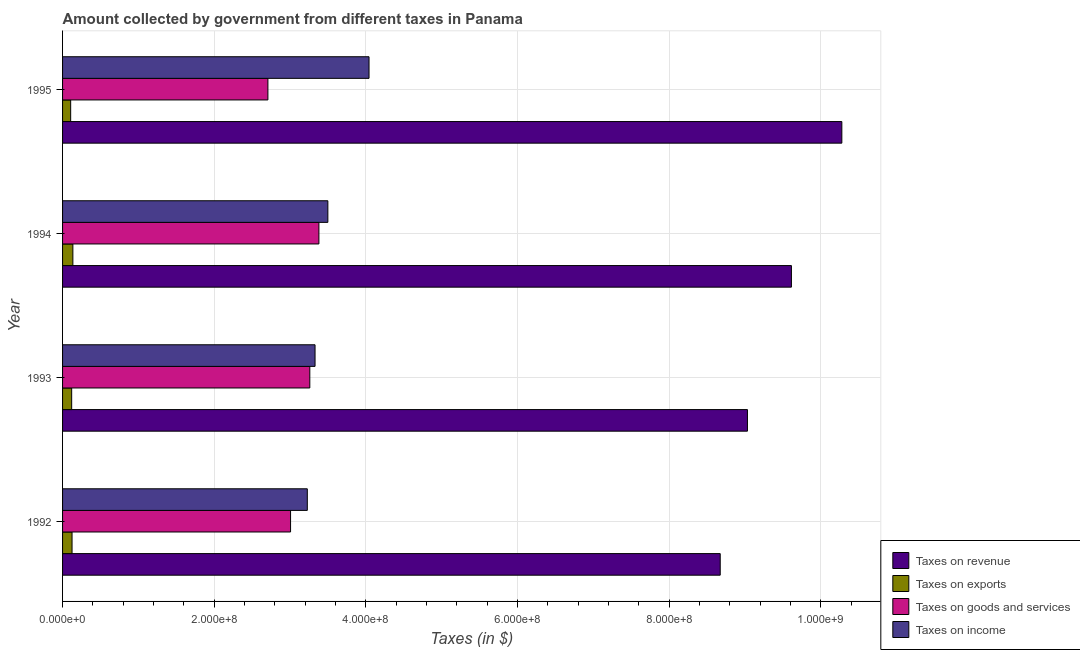How many groups of bars are there?
Keep it short and to the point. 4. Are the number of bars per tick equal to the number of legend labels?
Provide a succinct answer. Yes. Are the number of bars on each tick of the Y-axis equal?
Your response must be concise. Yes. What is the label of the 1st group of bars from the top?
Provide a short and direct response. 1995. In how many cases, is the number of bars for a given year not equal to the number of legend labels?
Ensure brevity in your answer.  0. What is the amount collected as tax on exports in 1994?
Provide a succinct answer. 1.36e+07. Across all years, what is the maximum amount collected as tax on goods?
Keep it short and to the point. 3.38e+08. Across all years, what is the minimum amount collected as tax on goods?
Ensure brevity in your answer.  2.71e+08. What is the total amount collected as tax on revenue in the graph?
Offer a very short reply. 3.76e+09. What is the difference between the amount collected as tax on exports in 1993 and that in 1994?
Provide a short and direct response. -1.60e+06. What is the difference between the amount collected as tax on income in 1994 and the amount collected as tax on revenue in 1995?
Offer a very short reply. -6.78e+08. What is the average amount collected as tax on revenue per year?
Your answer should be very brief. 9.40e+08. In the year 1995, what is the difference between the amount collected as tax on exports and amount collected as tax on income?
Keep it short and to the point. -3.94e+08. What is the ratio of the amount collected as tax on revenue in 1993 to that in 1995?
Make the answer very short. 0.88. Is the difference between the amount collected as tax on income in 1992 and 1993 greater than the difference between the amount collected as tax on goods in 1992 and 1993?
Your response must be concise. Yes. What is the difference between the highest and the second highest amount collected as tax on revenue?
Offer a very short reply. 6.65e+07. What is the difference between the highest and the lowest amount collected as tax on income?
Provide a short and direct response. 8.14e+07. In how many years, is the amount collected as tax on exports greater than the average amount collected as tax on exports taken over all years?
Offer a very short reply. 2. Is the sum of the amount collected as tax on revenue in 1993 and 1995 greater than the maximum amount collected as tax on exports across all years?
Your answer should be compact. Yes. What does the 4th bar from the top in 1995 represents?
Ensure brevity in your answer.  Taxes on revenue. What does the 1st bar from the bottom in 1994 represents?
Offer a terse response. Taxes on revenue. How many years are there in the graph?
Keep it short and to the point. 4. What is the difference between two consecutive major ticks on the X-axis?
Your answer should be very brief. 2.00e+08. Does the graph contain any zero values?
Your answer should be very brief. No. Does the graph contain grids?
Your answer should be very brief. Yes. Where does the legend appear in the graph?
Offer a very short reply. Bottom right. What is the title of the graph?
Give a very brief answer. Amount collected by government from different taxes in Panama. Does "Argument" appear as one of the legend labels in the graph?
Offer a terse response. No. What is the label or title of the X-axis?
Offer a very short reply. Taxes (in $). What is the label or title of the Y-axis?
Provide a succinct answer. Year. What is the Taxes (in $) of Taxes on revenue in 1992?
Provide a succinct answer. 8.67e+08. What is the Taxes (in $) of Taxes on exports in 1992?
Provide a succinct answer. 1.25e+07. What is the Taxes (in $) of Taxes on goods and services in 1992?
Provide a short and direct response. 3.01e+08. What is the Taxes (in $) of Taxes on income in 1992?
Provide a succinct answer. 3.23e+08. What is the Taxes (in $) in Taxes on revenue in 1993?
Your response must be concise. 9.03e+08. What is the Taxes (in $) in Taxes on goods and services in 1993?
Ensure brevity in your answer.  3.26e+08. What is the Taxes (in $) in Taxes on income in 1993?
Your answer should be compact. 3.33e+08. What is the Taxes (in $) in Taxes on revenue in 1994?
Your answer should be compact. 9.61e+08. What is the Taxes (in $) of Taxes on exports in 1994?
Your answer should be very brief. 1.36e+07. What is the Taxes (in $) of Taxes on goods and services in 1994?
Offer a very short reply. 3.38e+08. What is the Taxes (in $) in Taxes on income in 1994?
Offer a terse response. 3.50e+08. What is the Taxes (in $) of Taxes on revenue in 1995?
Provide a short and direct response. 1.03e+09. What is the Taxes (in $) in Taxes on exports in 1995?
Provide a short and direct response. 1.07e+07. What is the Taxes (in $) in Taxes on goods and services in 1995?
Give a very brief answer. 2.71e+08. What is the Taxes (in $) of Taxes on income in 1995?
Your answer should be compact. 4.04e+08. Across all years, what is the maximum Taxes (in $) of Taxes on revenue?
Offer a very short reply. 1.03e+09. Across all years, what is the maximum Taxes (in $) of Taxes on exports?
Ensure brevity in your answer.  1.36e+07. Across all years, what is the maximum Taxes (in $) of Taxes on goods and services?
Give a very brief answer. 3.38e+08. Across all years, what is the maximum Taxes (in $) in Taxes on income?
Your answer should be compact. 4.04e+08. Across all years, what is the minimum Taxes (in $) of Taxes on revenue?
Keep it short and to the point. 8.67e+08. Across all years, what is the minimum Taxes (in $) of Taxes on exports?
Your answer should be very brief. 1.07e+07. Across all years, what is the minimum Taxes (in $) of Taxes on goods and services?
Provide a succinct answer. 2.71e+08. Across all years, what is the minimum Taxes (in $) of Taxes on income?
Your response must be concise. 3.23e+08. What is the total Taxes (in $) of Taxes on revenue in the graph?
Provide a succinct answer. 3.76e+09. What is the total Taxes (in $) in Taxes on exports in the graph?
Provide a succinct answer. 4.88e+07. What is the total Taxes (in $) in Taxes on goods and services in the graph?
Ensure brevity in your answer.  1.24e+09. What is the total Taxes (in $) in Taxes on income in the graph?
Provide a succinct answer. 1.41e+09. What is the difference between the Taxes (in $) of Taxes on revenue in 1992 and that in 1993?
Your response must be concise. -3.59e+07. What is the difference between the Taxes (in $) of Taxes on exports in 1992 and that in 1993?
Offer a terse response. 5.00e+05. What is the difference between the Taxes (in $) of Taxes on goods and services in 1992 and that in 1993?
Provide a succinct answer. -2.54e+07. What is the difference between the Taxes (in $) of Taxes on income in 1992 and that in 1993?
Provide a short and direct response. -1.02e+07. What is the difference between the Taxes (in $) in Taxes on revenue in 1992 and that in 1994?
Make the answer very short. -9.39e+07. What is the difference between the Taxes (in $) of Taxes on exports in 1992 and that in 1994?
Give a very brief answer. -1.10e+06. What is the difference between the Taxes (in $) of Taxes on goods and services in 1992 and that in 1994?
Keep it short and to the point. -3.74e+07. What is the difference between the Taxes (in $) of Taxes on income in 1992 and that in 1994?
Give a very brief answer. -2.71e+07. What is the difference between the Taxes (in $) of Taxes on revenue in 1992 and that in 1995?
Give a very brief answer. -1.60e+08. What is the difference between the Taxes (in $) of Taxes on exports in 1992 and that in 1995?
Provide a succinct answer. 1.80e+06. What is the difference between the Taxes (in $) of Taxes on goods and services in 1992 and that in 1995?
Keep it short and to the point. 2.99e+07. What is the difference between the Taxes (in $) of Taxes on income in 1992 and that in 1995?
Your answer should be very brief. -8.14e+07. What is the difference between the Taxes (in $) of Taxes on revenue in 1993 and that in 1994?
Offer a very short reply. -5.80e+07. What is the difference between the Taxes (in $) of Taxes on exports in 1993 and that in 1994?
Provide a short and direct response. -1.60e+06. What is the difference between the Taxes (in $) of Taxes on goods and services in 1993 and that in 1994?
Your response must be concise. -1.20e+07. What is the difference between the Taxes (in $) of Taxes on income in 1993 and that in 1994?
Provide a short and direct response. -1.69e+07. What is the difference between the Taxes (in $) in Taxes on revenue in 1993 and that in 1995?
Give a very brief answer. -1.24e+08. What is the difference between the Taxes (in $) of Taxes on exports in 1993 and that in 1995?
Your response must be concise. 1.30e+06. What is the difference between the Taxes (in $) in Taxes on goods and services in 1993 and that in 1995?
Your answer should be very brief. 5.53e+07. What is the difference between the Taxes (in $) in Taxes on income in 1993 and that in 1995?
Your response must be concise. -7.12e+07. What is the difference between the Taxes (in $) of Taxes on revenue in 1994 and that in 1995?
Your response must be concise. -6.65e+07. What is the difference between the Taxes (in $) of Taxes on exports in 1994 and that in 1995?
Give a very brief answer. 2.90e+06. What is the difference between the Taxes (in $) in Taxes on goods and services in 1994 and that in 1995?
Ensure brevity in your answer.  6.73e+07. What is the difference between the Taxes (in $) in Taxes on income in 1994 and that in 1995?
Ensure brevity in your answer.  -5.43e+07. What is the difference between the Taxes (in $) of Taxes on revenue in 1992 and the Taxes (in $) of Taxes on exports in 1993?
Your answer should be very brief. 8.55e+08. What is the difference between the Taxes (in $) of Taxes on revenue in 1992 and the Taxes (in $) of Taxes on goods and services in 1993?
Offer a very short reply. 5.41e+08. What is the difference between the Taxes (in $) of Taxes on revenue in 1992 and the Taxes (in $) of Taxes on income in 1993?
Keep it short and to the point. 5.34e+08. What is the difference between the Taxes (in $) in Taxes on exports in 1992 and the Taxes (in $) in Taxes on goods and services in 1993?
Give a very brief answer. -3.14e+08. What is the difference between the Taxes (in $) in Taxes on exports in 1992 and the Taxes (in $) in Taxes on income in 1993?
Ensure brevity in your answer.  -3.20e+08. What is the difference between the Taxes (in $) in Taxes on goods and services in 1992 and the Taxes (in $) in Taxes on income in 1993?
Give a very brief answer. -3.23e+07. What is the difference between the Taxes (in $) of Taxes on revenue in 1992 and the Taxes (in $) of Taxes on exports in 1994?
Your answer should be very brief. 8.54e+08. What is the difference between the Taxes (in $) in Taxes on revenue in 1992 and the Taxes (in $) in Taxes on goods and services in 1994?
Your response must be concise. 5.29e+08. What is the difference between the Taxes (in $) of Taxes on revenue in 1992 and the Taxes (in $) of Taxes on income in 1994?
Your response must be concise. 5.18e+08. What is the difference between the Taxes (in $) of Taxes on exports in 1992 and the Taxes (in $) of Taxes on goods and services in 1994?
Your answer should be very brief. -3.26e+08. What is the difference between the Taxes (in $) in Taxes on exports in 1992 and the Taxes (in $) in Taxes on income in 1994?
Offer a terse response. -3.37e+08. What is the difference between the Taxes (in $) in Taxes on goods and services in 1992 and the Taxes (in $) in Taxes on income in 1994?
Your response must be concise. -4.92e+07. What is the difference between the Taxes (in $) in Taxes on revenue in 1992 and the Taxes (in $) in Taxes on exports in 1995?
Ensure brevity in your answer.  8.57e+08. What is the difference between the Taxes (in $) of Taxes on revenue in 1992 and the Taxes (in $) of Taxes on goods and services in 1995?
Your response must be concise. 5.97e+08. What is the difference between the Taxes (in $) in Taxes on revenue in 1992 and the Taxes (in $) in Taxes on income in 1995?
Keep it short and to the point. 4.63e+08. What is the difference between the Taxes (in $) of Taxes on exports in 1992 and the Taxes (in $) of Taxes on goods and services in 1995?
Offer a very short reply. -2.58e+08. What is the difference between the Taxes (in $) of Taxes on exports in 1992 and the Taxes (in $) of Taxes on income in 1995?
Make the answer very short. -3.92e+08. What is the difference between the Taxes (in $) in Taxes on goods and services in 1992 and the Taxes (in $) in Taxes on income in 1995?
Your answer should be very brief. -1.04e+08. What is the difference between the Taxes (in $) of Taxes on revenue in 1993 and the Taxes (in $) of Taxes on exports in 1994?
Your answer should be compact. 8.90e+08. What is the difference between the Taxes (in $) in Taxes on revenue in 1993 and the Taxes (in $) in Taxes on goods and services in 1994?
Your response must be concise. 5.65e+08. What is the difference between the Taxes (in $) of Taxes on revenue in 1993 and the Taxes (in $) of Taxes on income in 1994?
Your response must be concise. 5.53e+08. What is the difference between the Taxes (in $) in Taxes on exports in 1993 and the Taxes (in $) in Taxes on goods and services in 1994?
Provide a short and direct response. -3.26e+08. What is the difference between the Taxes (in $) in Taxes on exports in 1993 and the Taxes (in $) in Taxes on income in 1994?
Offer a terse response. -3.38e+08. What is the difference between the Taxes (in $) of Taxes on goods and services in 1993 and the Taxes (in $) of Taxes on income in 1994?
Offer a terse response. -2.38e+07. What is the difference between the Taxes (in $) of Taxes on revenue in 1993 and the Taxes (in $) of Taxes on exports in 1995?
Ensure brevity in your answer.  8.93e+08. What is the difference between the Taxes (in $) in Taxes on revenue in 1993 and the Taxes (in $) in Taxes on goods and services in 1995?
Make the answer very short. 6.32e+08. What is the difference between the Taxes (in $) in Taxes on revenue in 1993 and the Taxes (in $) in Taxes on income in 1995?
Offer a terse response. 4.99e+08. What is the difference between the Taxes (in $) in Taxes on exports in 1993 and the Taxes (in $) in Taxes on goods and services in 1995?
Keep it short and to the point. -2.59e+08. What is the difference between the Taxes (in $) in Taxes on exports in 1993 and the Taxes (in $) in Taxes on income in 1995?
Your response must be concise. -3.92e+08. What is the difference between the Taxes (in $) in Taxes on goods and services in 1993 and the Taxes (in $) in Taxes on income in 1995?
Ensure brevity in your answer.  -7.81e+07. What is the difference between the Taxes (in $) of Taxes on revenue in 1994 and the Taxes (in $) of Taxes on exports in 1995?
Offer a terse response. 9.51e+08. What is the difference between the Taxes (in $) in Taxes on revenue in 1994 and the Taxes (in $) in Taxes on goods and services in 1995?
Provide a short and direct response. 6.90e+08. What is the difference between the Taxes (in $) in Taxes on revenue in 1994 and the Taxes (in $) in Taxes on income in 1995?
Keep it short and to the point. 5.57e+08. What is the difference between the Taxes (in $) of Taxes on exports in 1994 and the Taxes (in $) of Taxes on goods and services in 1995?
Ensure brevity in your answer.  -2.57e+08. What is the difference between the Taxes (in $) of Taxes on exports in 1994 and the Taxes (in $) of Taxes on income in 1995?
Give a very brief answer. -3.91e+08. What is the difference between the Taxes (in $) in Taxes on goods and services in 1994 and the Taxes (in $) in Taxes on income in 1995?
Provide a short and direct response. -6.61e+07. What is the average Taxes (in $) of Taxes on revenue per year?
Your answer should be compact. 9.40e+08. What is the average Taxes (in $) in Taxes on exports per year?
Provide a succinct answer. 1.22e+07. What is the average Taxes (in $) of Taxes on goods and services per year?
Your response must be concise. 3.09e+08. What is the average Taxes (in $) in Taxes on income per year?
Ensure brevity in your answer.  3.52e+08. In the year 1992, what is the difference between the Taxes (in $) of Taxes on revenue and Taxes (in $) of Taxes on exports?
Keep it short and to the point. 8.55e+08. In the year 1992, what is the difference between the Taxes (in $) of Taxes on revenue and Taxes (in $) of Taxes on goods and services?
Your answer should be very brief. 5.67e+08. In the year 1992, what is the difference between the Taxes (in $) in Taxes on revenue and Taxes (in $) in Taxes on income?
Offer a terse response. 5.45e+08. In the year 1992, what is the difference between the Taxes (in $) of Taxes on exports and Taxes (in $) of Taxes on goods and services?
Provide a succinct answer. -2.88e+08. In the year 1992, what is the difference between the Taxes (in $) in Taxes on exports and Taxes (in $) in Taxes on income?
Offer a terse response. -3.10e+08. In the year 1992, what is the difference between the Taxes (in $) in Taxes on goods and services and Taxes (in $) in Taxes on income?
Your response must be concise. -2.21e+07. In the year 1993, what is the difference between the Taxes (in $) in Taxes on revenue and Taxes (in $) in Taxes on exports?
Provide a succinct answer. 8.91e+08. In the year 1993, what is the difference between the Taxes (in $) of Taxes on revenue and Taxes (in $) of Taxes on goods and services?
Keep it short and to the point. 5.77e+08. In the year 1993, what is the difference between the Taxes (in $) in Taxes on revenue and Taxes (in $) in Taxes on income?
Your answer should be very brief. 5.70e+08. In the year 1993, what is the difference between the Taxes (in $) of Taxes on exports and Taxes (in $) of Taxes on goods and services?
Your response must be concise. -3.14e+08. In the year 1993, what is the difference between the Taxes (in $) of Taxes on exports and Taxes (in $) of Taxes on income?
Your answer should be very brief. -3.21e+08. In the year 1993, what is the difference between the Taxes (in $) of Taxes on goods and services and Taxes (in $) of Taxes on income?
Your answer should be compact. -6.90e+06. In the year 1994, what is the difference between the Taxes (in $) of Taxes on revenue and Taxes (in $) of Taxes on exports?
Offer a terse response. 9.48e+08. In the year 1994, what is the difference between the Taxes (in $) in Taxes on revenue and Taxes (in $) in Taxes on goods and services?
Give a very brief answer. 6.23e+08. In the year 1994, what is the difference between the Taxes (in $) of Taxes on revenue and Taxes (in $) of Taxes on income?
Offer a terse response. 6.11e+08. In the year 1994, what is the difference between the Taxes (in $) in Taxes on exports and Taxes (in $) in Taxes on goods and services?
Offer a terse response. -3.24e+08. In the year 1994, what is the difference between the Taxes (in $) of Taxes on exports and Taxes (in $) of Taxes on income?
Ensure brevity in your answer.  -3.36e+08. In the year 1994, what is the difference between the Taxes (in $) of Taxes on goods and services and Taxes (in $) of Taxes on income?
Offer a terse response. -1.18e+07. In the year 1995, what is the difference between the Taxes (in $) in Taxes on revenue and Taxes (in $) in Taxes on exports?
Make the answer very short. 1.02e+09. In the year 1995, what is the difference between the Taxes (in $) of Taxes on revenue and Taxes (in $) of Taxes on goods and services?
Offer a very short reply. 7.57e+08. In the year 1995, what is the difference between the Taxes (in $) of Taxes on revenue and Taxes (in $) of Taxes on income?
Your answer should be very brief. 6.24e+08. In the year 1995, what is the difference between the Taxes (in $) in Taxes on exports and Taxes (in $) in Taxes on goods and services?
Your answer should be compact. -2.60e+08. In the year 1995, what is the difference between the Taxes (in $) in Taxes on exports and Taxes (in $) in Taxes on income?
Provide a short and direct response. -3.94e+08. In the year 1995, what is the difference between the Taxes (in $) of Taxes on goods and services and Taxes (in $) of Taxes on income?
Keep it short and to the point. -1.33e+08. What is the ratio of the Taxes (in $) in Taxes on revenue in 1992 to that in 1993?
Keep it short and to the point. 0.96. What is the ratio of the Taxes (in $) in Taxes on exports in 1992 to that in 1993?
Your answer should be very brief. 1.04. What is the ratio of the Taxes (in $) of Taxes on goods and services in 1992 to that in 1993?
Your response must be concise. 0.92. What is the ratio of the Taxes (in $) in Taxes on income in 1992 to that in 1993?
Ensure brevity in your answer.  0.97. What is the ratio of the Taxes (in $) of Taxes on revenue in 1992 to that in 1994?
Your answer should be compact. 0.9. What is the ratio of the Taxes (in $) in Taxes on exports in 1992 to that in 1994?
Keep it short and to the point. 0.92. What is the ratio of the Taxes (in $) of Taxes on goods and services in 1992 to that in 1994?
Ensure brevity in your answer.  0.89. What is the ratio of the Taxes (in $) in Taxes on income in 1992 to that in 1994?
Keep it short and to the point. 0.92. What is the ratio of the Taxes (in $) of Taxes on revenue in 1992 to that in 1995?
Make the answer very short. 0.84. What is the ratio of the Taxes (in $) of Taxes on exports in 1992 to that in 1995?
Your answer should be very brief. 1.17. What is the ratio of the Taxes (in $) in Taxes on goods and services in 1992 to that in 1995?
Make the answer very short. 1.11. What is the ratio of the Taxes (in $) in Taxes on income in 1992 to that in 1995?
Your answer should be compact. 0.8. What is the ratio of the Taxes (in $) in Taxes on revenue in 1993 to that in 1994?
Ensure brevity in your answer.  0.94. What is the ratio of the Taxes (in $) in Taxes on exports in 1993 to that in 1994?
Make the answer very short. 0.88. What is the ratio of the Taxes (in $) in Taxes on goods and services in 1993 to that in 1994?
Ensure brevity in your answer.  0.96. What is the ratio of the Taxes (in $) in Taxes on income in 1993 to that in 1994?
Your answer should be very brief. 0.95. What is the ratio of the Taxes (in $) of Taxes on revenue in 1993 to that in 1995?
Provide a succinct answer. 0.88. What is the ratio of the Taxes (in $) in Taxes on exports in 1993 to that in 1995?
Provide a short and direct response. 1.12. What is the ratio of the Taxes (in $) of Taxes on goods and services in 1993 to that in 1995?
Give a very brief answer. 1.2. What is the ratio of the Taxes (in $) of Taxes on income in 1993 to that in 1995?
Ensure brevity in your answer.  0.82. What is the ratio of the Taxes (in $) in Taxes on revenue in 1994 to that in 1995?
Keep it short and to the point. 0.94. What is the ratio of the Taxes (in $) of Taxes on exports in 1994 to that in 1995?
Your answer should be compact. 1.27. What is the ratio of the Taxes (in $) in Taxes on goods and services in 1994 to that in 1995?
Ensure brevity in your answer.  1.25. What is the ratio of the Taxes (in $) in Taxes on income in 1994 to that in 1995?
Make the answer very short. 0.87. What is the difference between the highest and the second highest Taxes (in $) of Taxes on revenue?
Provide a succinct answer. 6.65e+07. What is the difference between the highest and the second highest Taxes (in $) in Taxes on exports?
Offer a very short reply. 1.10e+06. What is the difference between the highest and the second highest Taxes (in $) in Taxes on goods and services?
Offer a terse response. 1.20e+07. What is the difference between the highest and the second highest Taxes (in $) of Taxes on income?
Provide a succinct answer. 5.43e+07. What is the difference between the highest and the lowest Taxes (in $) in Taxes on revenue?
Your response must be concise. 1.60e+08. What is the difference between the highest and the lowest Taxes (in $) of Taxes on exports?
Keep it short and to the point. 2.90e+06. What is the difference between the highest and the lowest Taxes (in $) of Taxes on goods and services?
Give a very brief answer. 6.73e+07. What is the difference between the highest and the lowest Taxes (in $) in Taxes on income?
Your answer should be very brief. 8.14e+07. 